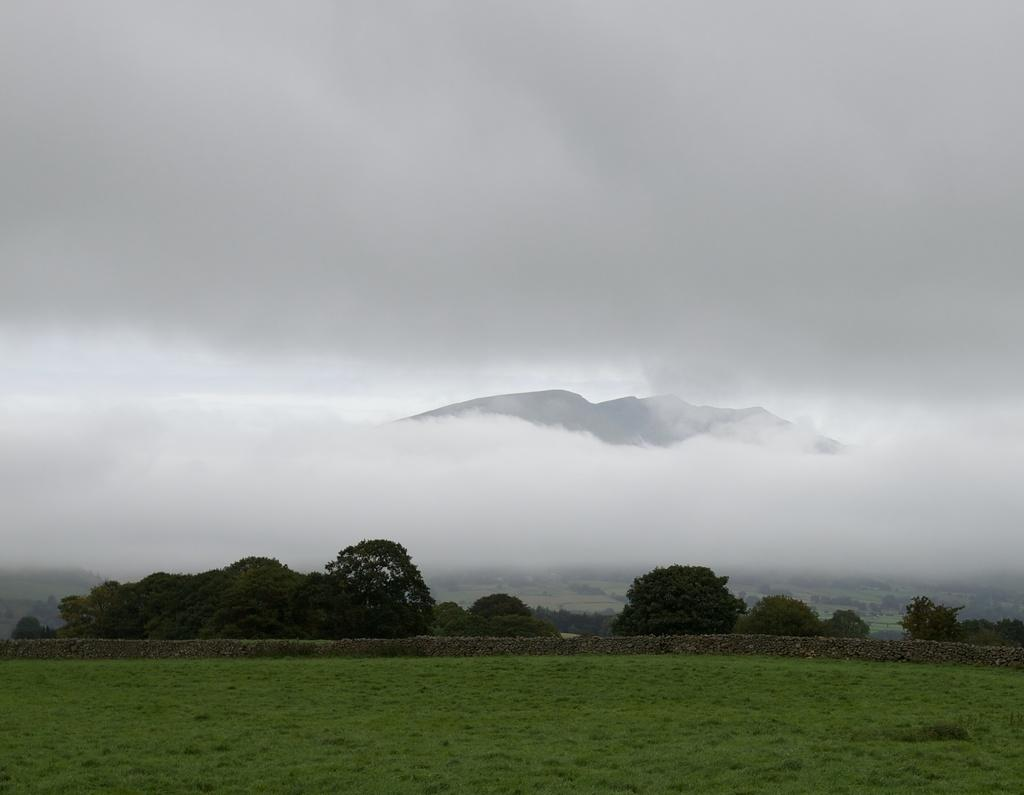What type of vegetation can be seen in the image? There is green grass in the image. What other natural elements are present in the image? There are trees in the image. What is the condition of the sky in the background? The sky is cloudy in the background. What man-made structure can be seen in the background? There is a wall visible in the background. What type of balls are being used to play a game on the grass in the image? There are no balls or games visible in the image; it only features green grass, trees, a cloudy sky, and a wall in the background. 